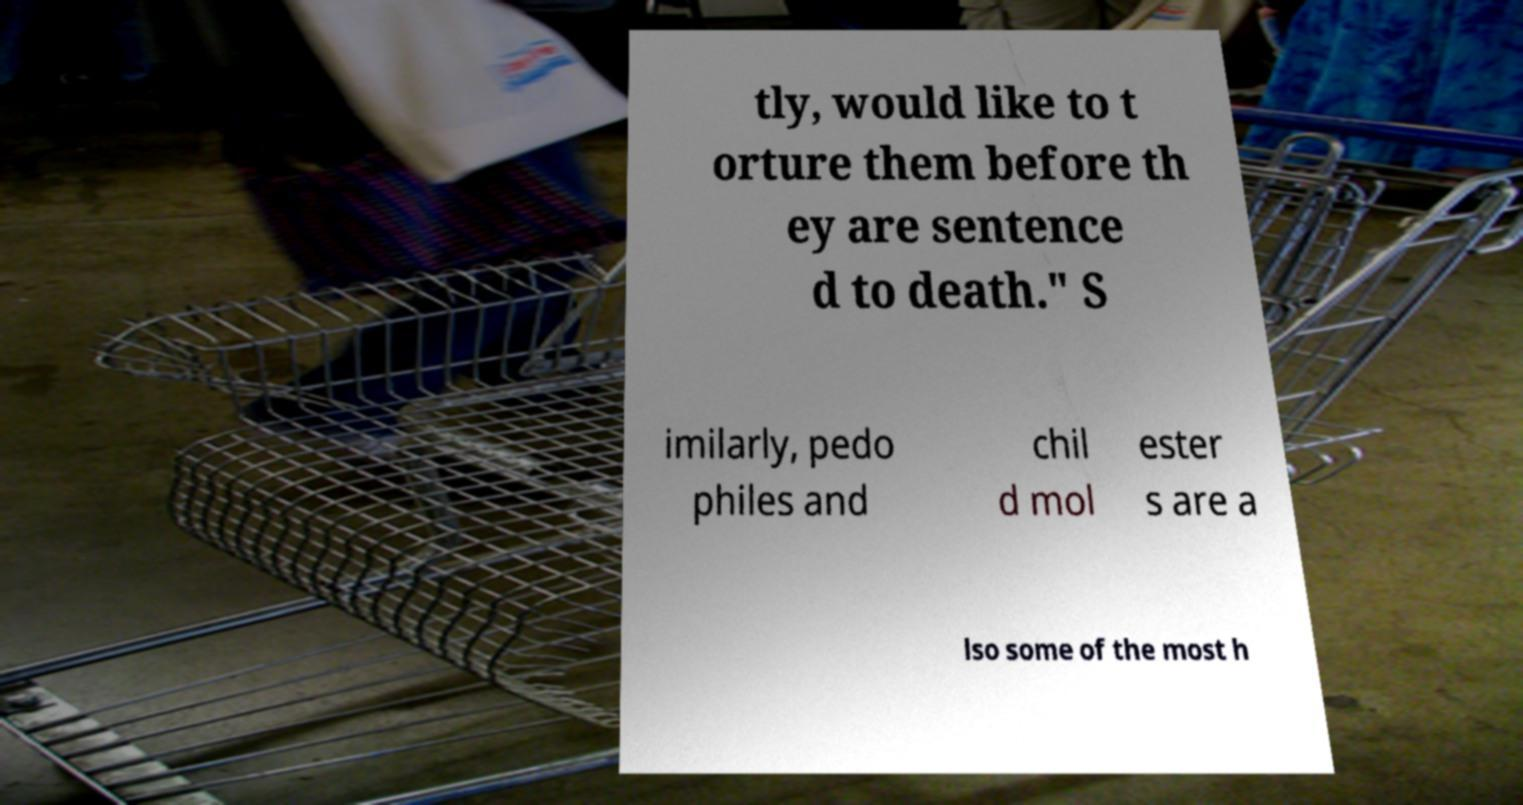Could you extract and type out the text from this image? tly, would like to t orture them before th ey are sentence d to death." S imilarly, pedo philes and chil d mol ester s are a lso some of the most h 